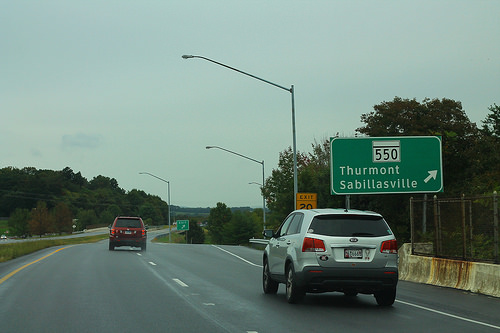<image>
Can you confirm if the car is under the tree? No. The car is not positioned under the tree. The vertical relationship between these objects is different. 